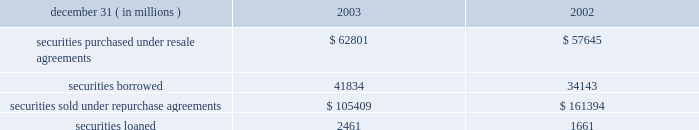Notes to consolidated financial statements j.p .
Morgan chase & co .
98 j.p .
Morgan chase & co .
/ 2003 annual report securities financing activities jpmorgan chase enters into resale agreements , repurchase agreements , securities borrowed transactions and securities loaned transactions primarily to finance the firm 2019s inventory positions , acquire securities to cover short positions and settle other securities obligations .
The firm also enters into these transactions to accommodate customers 2019 needs .
Securities purchased under resale agreements ( 201cresale agreements 201d ) and securities sold under repurchase agreements ( 201crepurchase agreements 201d ) are generally treated as collateralized financing transactions and are carried on the consolidated bal- ance sheet at the amounts the securities will be subsequently sold or repurchased , plus accrued interest .
Where appropriate , resale and repurchase agreements with the same counterparty are reported on a net basis in accordance with fin 41 .
Jpmorgan chase takes possession of securities purchased under resale agreements .
On a daily basis , jpmorgan chase monitors the market value of the underlying collateral received from its counterparties , consisting primarily of u.s .
And non-u.s .
Govern- ment and agency securities , and requests additional collateral from its counterparties when necessary .
Similar transactions that do not meet the sfas 140 definition of a repurchase agreement are accounted for as 201cbuys 201d and 201csells 201d rather than financing transactions .
These transactions are accounted for as a purchase ( sale ) of the underlying securities with a forward obligation to sell ( purchase ) the securities .
The forward purchase ( sale ) obligation , a derivative , is recorded on the consolidated balance sheet at its fair value , with changes in fair value recorded in trading revenue .
Notional amounts of these transactions accounted for as purchases under sfas 140 were $ 15 billion and $ 8 billion at december 31 , 2003 and 2002 , respectively .
Notional amounts of these transactions accounted for as sales under sfas 140 were $ 8 billion and $ 13 billion at december 31 , 2003 and 2002 , respectively .
Based on the short-term duration of these contracts , the unrealized gain or loss is insignificant .
Securities borrowed and securities lent are recorded at the amount of cash collateral advanced or received .
Securities bor- rowed consist primarily of government and equity securities .
Jpmorgan chase monitors the market value of the securities borrowed and lent on a daily basis and calls for additional col- lateral when appropriate .
Fees received or paid are recorded in interest income or interest expense. .
Note 10 jpmorgan chase pledges certain financial instruments it owns to collateralize repurchase agreements and other securities financ- ings .
Pledged securities that can be sold or repledged by the secured party are identified as financial instruments owned ( pledged to various parties ) on the consolidated balance sheet .
At december 31 , 2003 , the firm had received securities as col- lateral that can be repledged , delivered or otherwise used with a fair value of approximately $ 210 billion .
This collateral was gen- erally obtained under resale or securities-borrowing agreements .
Of these securities , approximately $ 197 billion was repledged , delivered or otherwise used , generally as collateral under repur- chase agreements , securities-lending agreements or to cover short sales .
Notes to consolidated financial statements j.p .
Morgan chase & co .
Loans are reported at the principal amount outstanding , net of the allowance for loan losses , unearned income and any net deferred loan fees .
Loans held for sale are carried at the lower of aggregate cost or fair value .
Loans are classified as 201ctrading 201d for secondary market trading activities where positions are bought and sold to make profits from short-term movements in price .
Loans held for trading purposes are included in trading assets and are carried at fair value , with the gains and losses included in trading revenue .
Interest income is recognized using the interest method , or on a basis approximating a level rate of return over the term of the loan .
Nonaccrual loans are those on which the accrual of interest is discontinued .
Loans ( other than certain consumer loans discussed below ) are placed on nonaccrual status immediately if , in the opinion of management , full payment of principal or interest is in doubt , or when principal or interest is 90 days or more past due and collateral , if any , is insufficient to cover prin- cipal and interest .
Interest accrued but not collected at the date a loan is placed on nonaccrual status is reversed against interest income .
In addition , the amortization of net deferred loan fees is suspended .
Interest income on nonaccrual loans is recognized only to the extent it is received in cash .
However , where there is doubt regarding the ultimate collectibility of loan principal , all cash thereafter received is applied to reduce the carrying value of the loan .
Loans are restored to accrual status only when interest and principal payments are brought current and future payments are reasonably assured .
Consumer loans are generally charged to the allowance for loan losses upon reaching specified stages of delinquency , in accor- dance with the federal financial institutions examination council ( 201cffiec 201d ) policy .
For example , credit card loans are charged off at the earlier of 180 days past due or within 60 days from receiving notification of the filing of bankruptcy .
Residential mortgage products are generally charged off to net realizable value at 180 days past due .
Other consumer products are gener- ally charged off ( to net realizable value if collateralized ) at 120 days past due .
Accrued interest on residential mortgage products , automobile financings and certain other consumer loans are accounted for in accordance with the nonaccrual loan policy note 11 .
Do residential mortgage products have a longer past due period than other consumer products ? .? 
Computations: (180 > 120)
Answer: yes. 